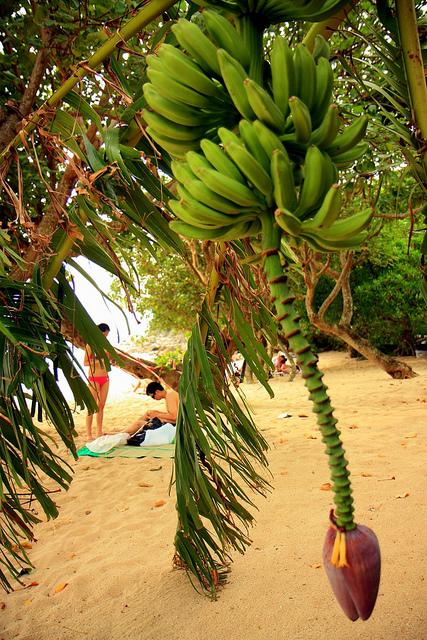What kind of swimsuit is the girl wearing?
Keep it brief. Bikini. Is the fruit ripe?
Concise answer only. No. Are the bananas ready to be picked?
Write a very short answer. No. What kind of tree is this?
Give a very brief answer. Banana. 